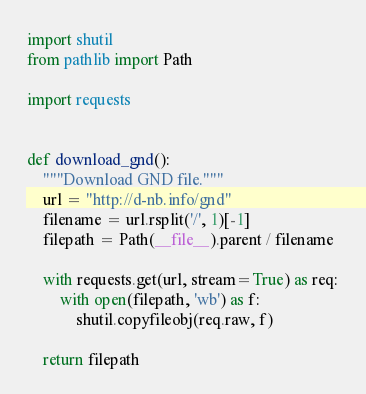<code> <loc_0><loc_0><loc_500><loc_500><_Python_>import shutil
from pathlib import Path

import requests


def download_gnd():
    """Download GND file."""
    url = "http://d-nb.info/gnd"
    filename = url.rsplit('/', 1)[-1]
    filepath = Path(__file__).parent / filename

    with requests.get(url, stream=True) as req:
        with open(filepath, 'wb') as f:
            shutil.copyfileobj(req.raw, f)

    return filepath
</code> 